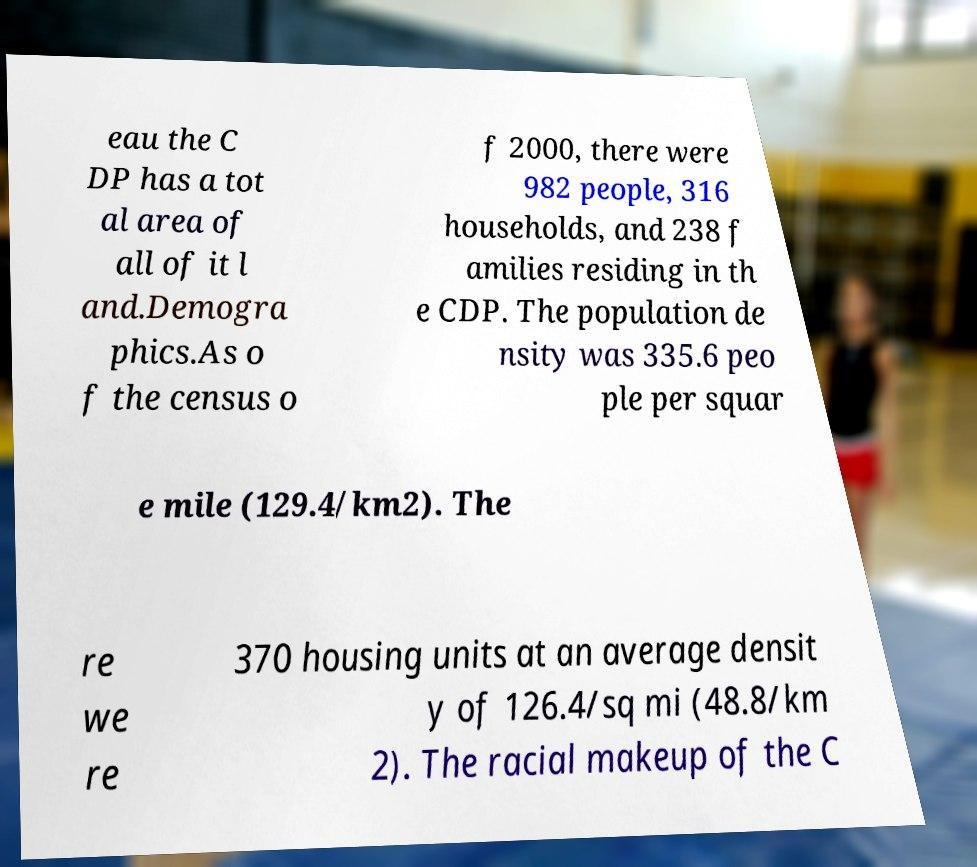Can you accurately transcribe the text from the provided image for me? eau the C DP has a tot al area of all of it l and.Demogra phics.As o f the census o f 2000, there were 982 people, 316 households, and 238 f amilies residing in th e CDP. The population de nsity was 335.6 peo ple per squar e mile (129.4/km2). The re we re 370 housing units at an average densit y of 126.4/sq mi (48.8/km 2). The racial makeup of the C 